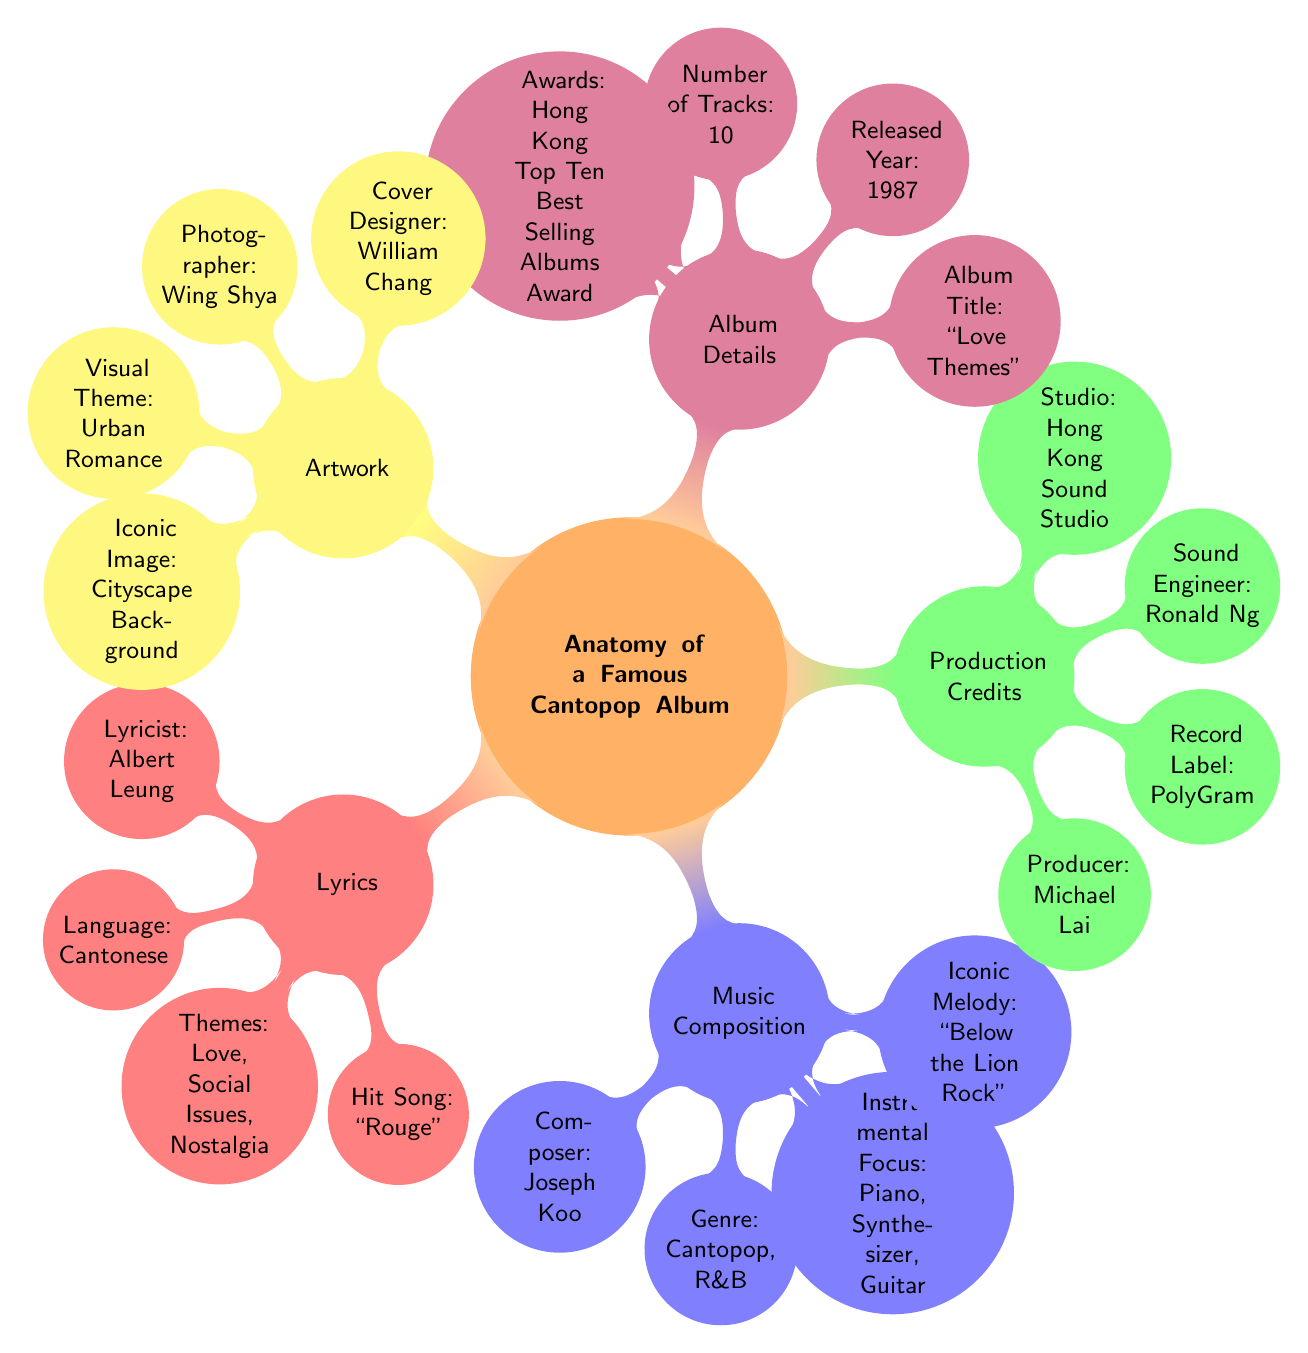What is the title of the album? The title of the album is found in the "Album Details" section, where it is directly mentioned as "Love Themes".
Answer: Love Themes Who is the producer of the album? To find the producer, we look at the "Production Credits" section, which lists the producer as Michael Lai.
Answer: Michael Lai In what year was the album released? The release year is specified in the "Album Details" section, noted as 1987.
Answer: 1987 What genre does this album belong to? The "Music Composition" section provides this information, indicating that the genre is Cantopop and R&B.
Answer: Cantopop, R&B How many tracks are on the album? The number of tracks can be located in the "Album Details" section, which states there are 10 tracks.
Answer: 10 What are the themes of the lyrics? The "Lyrics" section outlines the themes of the lyrics, which include love, social issues, and nostalgia.
Answer: Love, Social Issues, Nostalgia Who designed the album cover? This information is found in the "Artwork" section, which identifies the cover designer as William Chang.
Answer: William Chang What instrument is highlighted in the music composition? The "Music Composition" section mentions the instrumental focus includes piano, synthesizer, and guitar; highlighting piano.
Answer: Piano What is the iconic image on the album cover? The "Artwork" section notes the iconic image is a cityscape background, describing the visual aspect of the album cover.
Answer: Cityscape Background 